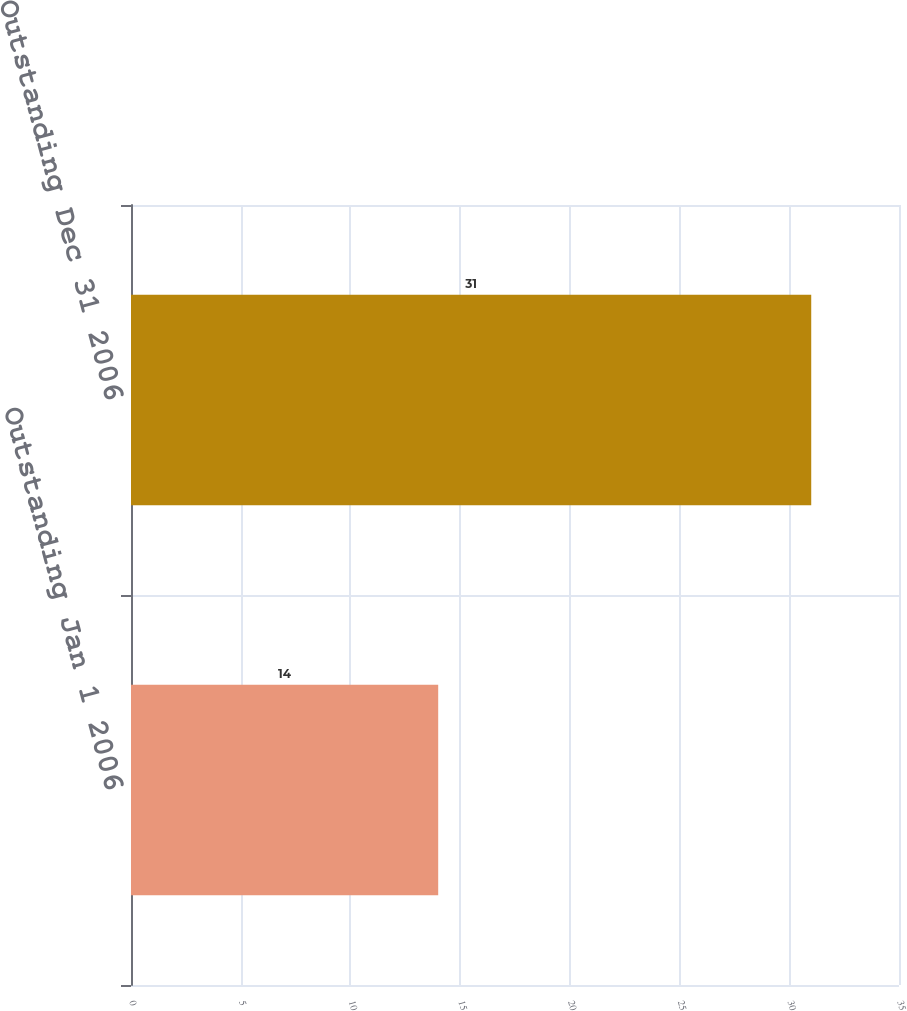<chart> <loc_0><loc_0><loc_500><loc_500><bar_chart><fcel>Outstanding Jan 1 2006<fcel>Outstanding Dec 31 2006<nl><fcel>14<fcel>31<nl></chart> 